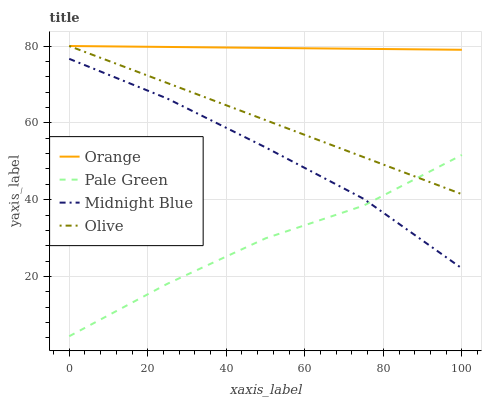Does Pale Green have the minimum area under the curve?
Answer yes or no. Yes. Does Orange have the maximum area under the curve?
Answer yes or no. Yes. Does Olive have the minimum area under the curve?
Answer yes or no. No. Does Olive have the maximum area under the curve?
Answer yes or no. No. Is Orange the smoothest?
Answer yes or no. Yes. Is Pale Green the roughest?
Answer yes or no. Yes. Is Olive the smoothest?
Answer yes or no. No. Is Olive the roughest?
Answer yes or no. No. Does Pale Green have the lowest value?
Answer yes or no. Yes. Does Olive have the lowest value?
Answer yes or no. No. Does Olive have the highest value?
Answer yes or no. Yes. Does Pale Green have the highest value?
Answer yes or no. No. Is Pale Green less than Orange?
Answer yes or no. Yes. Is Orange greater than Pale Green?
Answer yes or no. Yes. Does Pale Green intersect Olive?
Answer yes or no. Yes. Is Pale Green less than Olive?
Answer yes or no. No. Is Pale Green greater than Olive?
Answer yes or no. No. Does Pale Green intersect Orange?
Answer yes or no. No. 